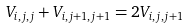<formula> <loc_0><loc_0><loc_500><loc_500>V _ { i , j , j } + V _ { i , j + 1 , j + 1 } = 2 V _ { i , j , j + 1 }</formula> 